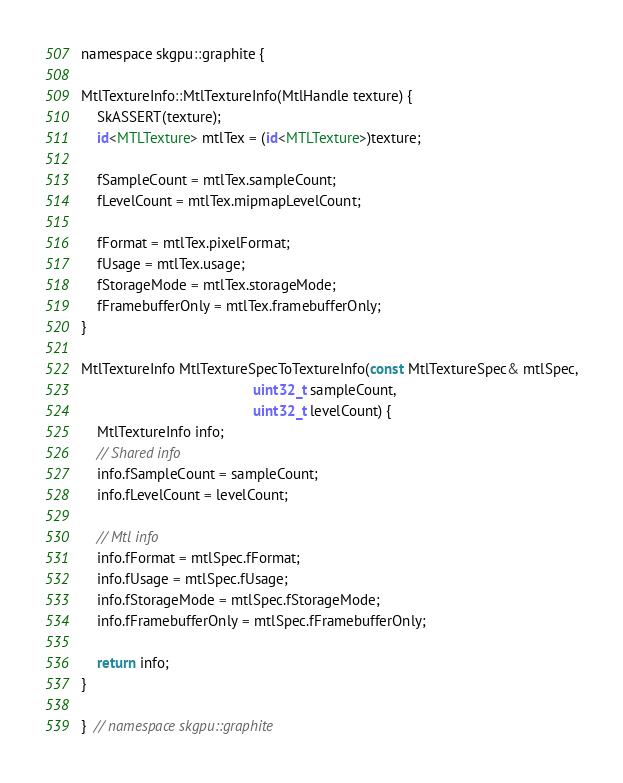Convert code to text. <code><loc_0><loc_0><loc_500><loc_500><_ObjectiveC_>namespace skgpu::graphite {

MtlTextureInfo::MtlTextureInfo(MtlHandle texture) {
    SkASSERT(texture);
    id<MTLTexture> mtlTex = (id<MTLTexture>)texture;

    fSampleCount = mtlTex.sampleCount;
    fLevelCount = mtlTex.mipmapLevelCount;

    fFormat = mtlTex.pixelFormat;
    fUsage = mtlTex.usage;
    fStorageMode = mtlTex.storageMode;
    fFramebufferOnly = mtlTex.framebufferOnly;
}

MtlTextureInfo MtlTextureSpecToTextureInfo(const MtlTextureSpec& mtlSpec,
                                           uint32_t sampleCount,
                                           uint32_t levelCount) {
    MtlTextureInfo info;
    // Shared info
    info.fSampleCount = sampleCount;
    info.fLevelCount = levelCount;

    // Mtl info
    info.fFormat = mtlSpec.fFormat;
    info.fUsage = mtlSpec.fUsage;
    info.fStorageMode = mtlSpec.fStorageMode;
    info.fFramebufferOnly = mtlSpec.fFramebufferOnly;

    return info;
}

}  // namespace skgpu::graphite
</code> 